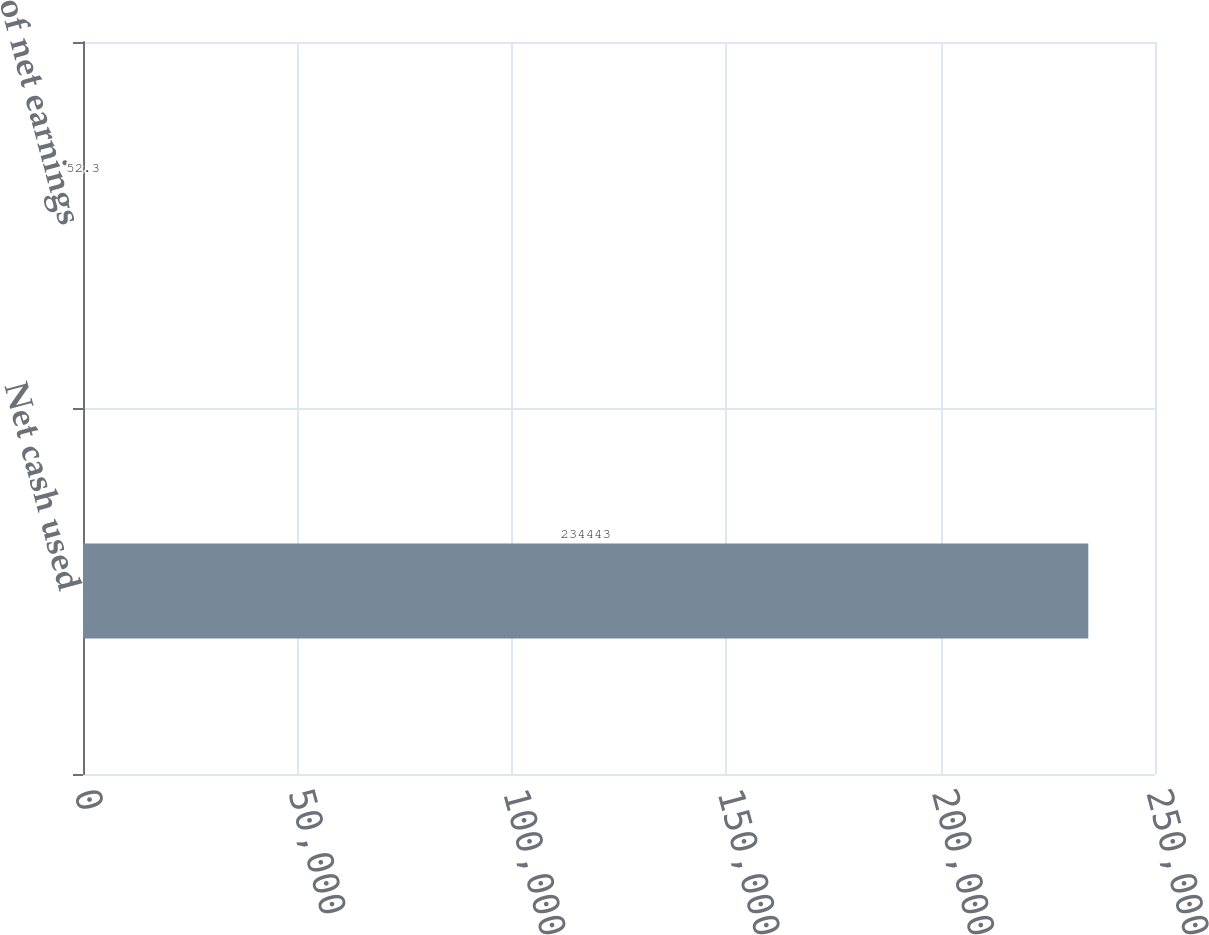<chart> <loc_0><loc_0><loc_500><loc_500><bar_chart><fcel>Net cash used<fcel>of net earnings<nl><fcel>234443<fcel>52.3<nl></chart> 